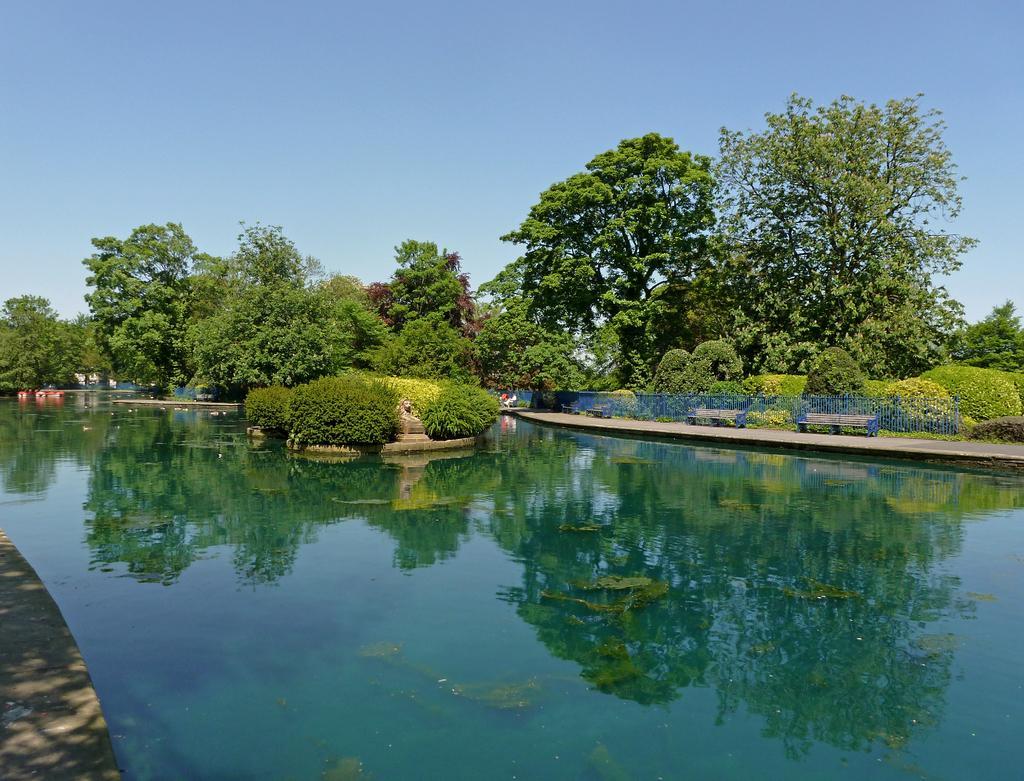Please provide a concise description of this image. In the foreground of the image we can see water body. In the middle of the image we can see trees. On the top of the image we can see the sky. 